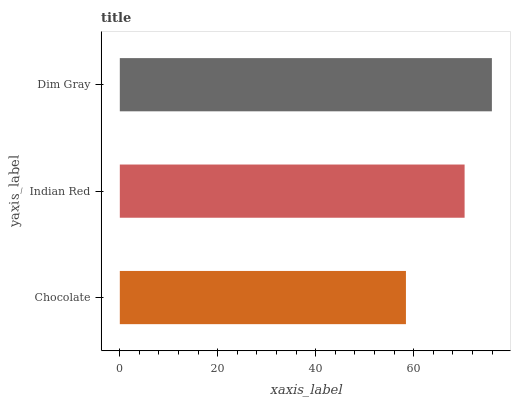Is Chocolate the minimum?
Answer yes or no. Yes. Is Dim Gray the maximum?
Answer yes or no. Yes. Is Indian Red the minimum?
Answer yes or no. No. Is Indian Red the maximum?
Answer yes or no. No. Is Indian Red greater than Chocolate?
Answer yes or no. Yes. Is Chocolate less than Indian Red?
Answer yes or no. Yes. Is Chocolate greater than Indian Red?
Answer yes or no. No. Is Indian Red less than Chocolate?
Answer yes or no. No. Is Indian Red the high median?
Answer yes or no. Yes. Is Indian Red the low median?
Answer yes or no. Yes. Is Chocolate the high median?
Answer yes or no. No. Is Dim Gray the low median?
Answer yes or no. No. 